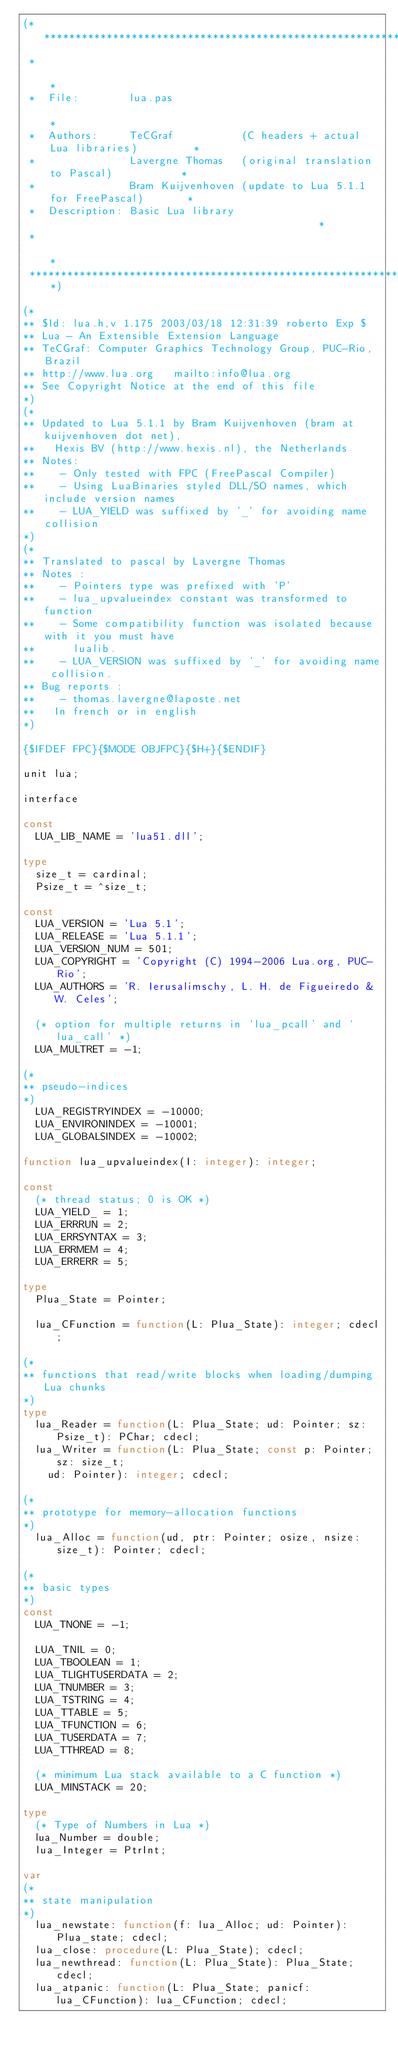<code> <loc_0><loc_0><loc_500><loc_500><_Pascal_>(******************************************************************************
 *                                                                            *
 *  File:        lua.pas                                                      *
 *  Authors:     TeCGraf           (C headers + actual Lua libraries)         *
 *               Lavergne Thomas   (original translation to Pascal)           *
 *               Bram Kuijvenhoven (update to Lua 5.1.1 for FreePascal)       *
 *  Description: Basic Lua library                                            *
 *                                                                            *
 ******************************************************************************)

(*
** $Id: lua.h,v 1.175 2003/03/18 12:31:39 roberto Exp $
** Lua - An Extensible Extension Language
** TeCGraf: Computer Graphics Technology Group, PUC-Rio, Brazil
** http://www.lua.org   mailto:info@lua.org
** See Copyright Notice at the end of this file
*)
(*
** Updated to Lua 5.1.1 by Bram Kuijvenhoven (bram at kuijvenhoven dot net),
**   Hexis BV (http://www.hexis.nl), the Netherlands
** Notes:
**    - Only tested with FPC (FreePascal Compiler)
**    - Using LuaBinaries styled DLL/SO names, which include version names
**    - LUA_YIELD was suffixed by '_' for avoiding name collision
*)
(*
** Translated to pascal by Lavergne Thomas
** Notes :
**    - Pointers type was prefixed with 'P'
**    - lua_upvalueindex constant was transformed to function
**    - Some compatibility function was isolated because with it you must have
**      lualib.
**    - LUA_VERSION was suffixed by '_' for avoiding name collision.
** Bug reports :
**    - thomas.lavergne@laposte.net
**   In french or in english
*)

{$IFDEF FPC}{$MODE OBJFPC}{$H+}{$ENDIF}

unit lua;

interface

const
  LUA_LIB_NAME = 'lua51.dll';

type
  size_t = cardinal;
  Psize_t = ^size_t;

const
  LUA_VERSION = 'Lua 5.1';
  LUA_RELEASE = 'Lua 5.1.1';
  LUA_VERSION_NUM = 501;
  LUA_COPYRIGHT = 'Copyright (C) 1994-2006 Lua.org, PUC-Rio';
  LUA_AUTHORS = 'R. Ierusalimschy, L. H. de Figueiredo & W. Celes';

  (* option for multiple returns in `lua_pcall' and `lua_call' *)
  LUA_MULTRET = -1;

(*
** pseudo-indices
*)
  LUA_REGISTRYINDEX = -10000;
  LUA_ENVIRONINDEX = -10001;
  LUA_GLOBALSINDEX = -10002;

function lua_upvalueindex(I: integer): integer;

const
  (* thread status; 0 is OK *)
  LUA_YIELD_ = 1;
  LUA_ERRRUN = 2;
  LUA_ERRSYNTAX = 3;
  LUA_ERRMEM = 4;
  LUA_ERRERR = 5;

type
  Plua_State = Pointer;

  lua_CFunction = function(L: Plua_State): integer; cdecl;

(*
** functions that read/write blocks when loading/dumping Lua chunks
*)
type
  lua_Reader = function(L: Plua_State; ud: Pointer; sz: Psize_t): PChar; cdecl;
  lua_Writer = function(L: Plua_State; const p: Pointer; sz: size_t;
    ud: Pointer): integer; cdecl;

(*
** prototype for memory-allocation functions
*)
  lua_Alloc = function(ud, ptr: Pointer; osize, nsize: size_t): Pointer; cdecl;

(*
** basic types
*)
const
  LUA_TNONE = -1;

  LUA_TNIL = 0;
  LUA_TBOOLEAN = 1;
  LUA_TLIGHTUSERDATA = 2;
  LUA_TNUMBER = 3;
  LUA_TSTRING = 4;
  LUA_TTABLE = 5;
  LUA_TFUNCTION = 6;
  LUA_TUSERDATA = 7;
  LUA_TTHREAD = 8;

  (* minimum Lua stack available to a C function *)
  LUA_MINSTACK = 20;

type
  (* Type of Numbers in Lua *)
  lua_Number = double;
  lua_Integer = PtrInt;

var
(*
** state manipulation
*)
  lua_newstate: function(f: lua_Alloc; ud: Pointer): Plua_state; cdecl;
  lua_close: procedure(L: Plua_State); cdecl;
  lua_newthread: function(L: Plua_State): Plua_State; cdecl;
  lua_atpanic: function(L: Plua_State; panicf: lua_CFunction): lua_CFunction; cdecl;
</code> 